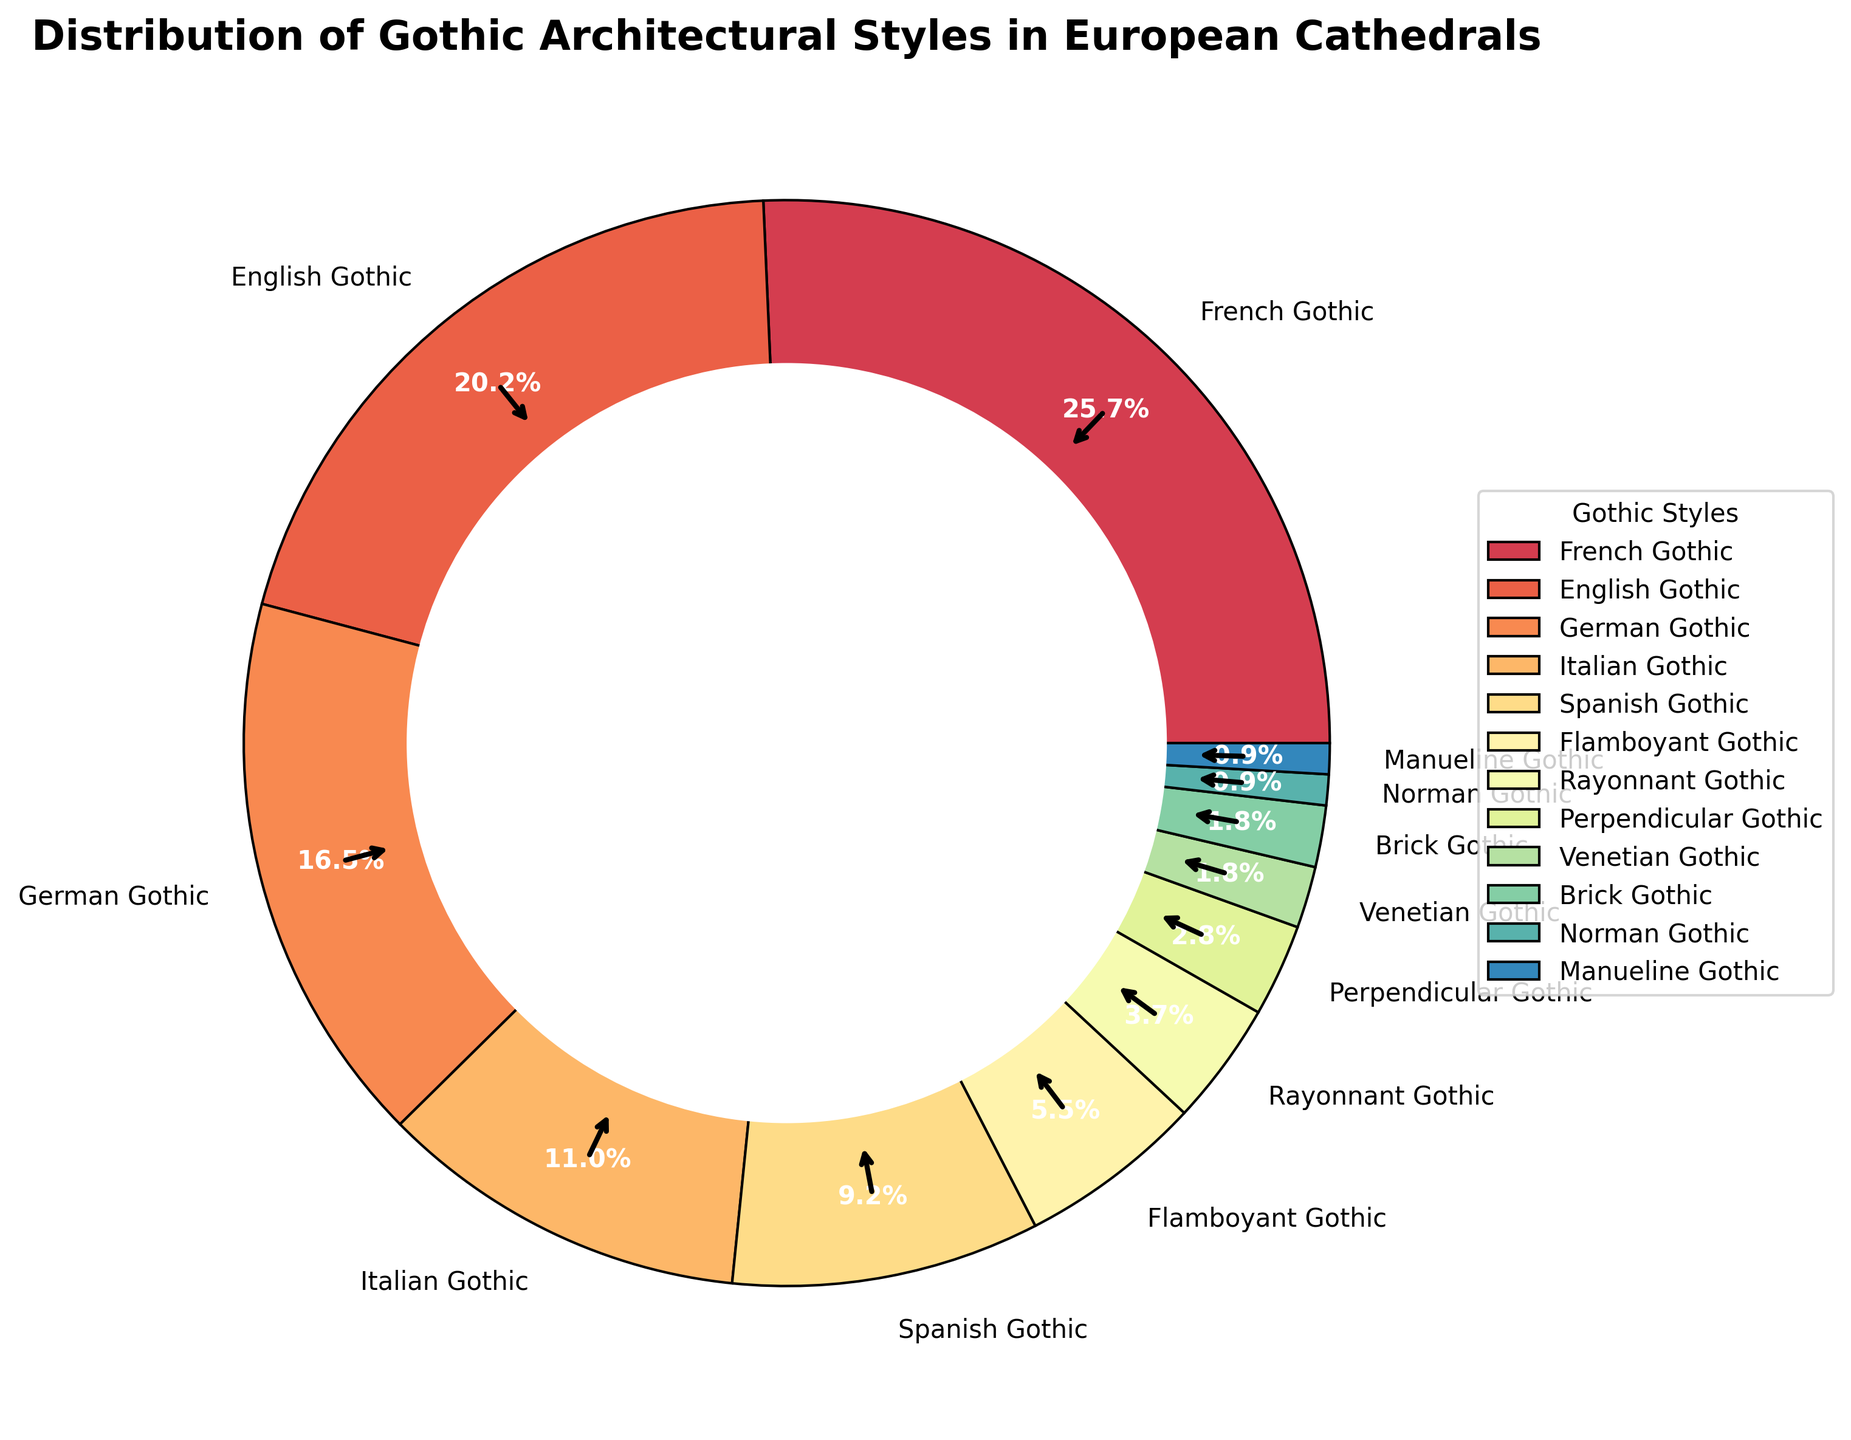What percentage of cathedrals exhibit French Gothic style? To find this information, look at the sector labeled "French Gothic" in the pie chart and note the percentage displayed on it.
Answer: 28% Of the main Gothic styles (French, English, German, Italian, and Spanish), which style has the smallest representation percentage? Among the prominent styles, look at the sectors labeled "French Gothic", "English Gothic", "German Gothic", "Italian Gothic", and "Spanish Gothic". Compare the percentages and identify the smallest.
Answer: Spanish Gothic How much larger is the percentage of French Gothic compared to Brick Gothic? Locate the percentages for "French Gothic" and "Brick Gothic", then subtract the Brick Gothic percentage from the French Gothic percentage. French Gothic is 28% and Brick Gothic is 2%, so the difference is 28% - 2%.
Answer: 26% Which two styles have the smallest segments in the pie chart? Find the smallest sectors in the pie chart and read their labels to identify the corresponding styles.
Answer: Norman Gothic and Manueline Gothic What is the combined percentage of Flamboyant Gothic, Rayonnant Gothic, and Perpendicular Gothic styles? Look for the percentages of "Flamboyant Gothic" (6%), "Rayonnant Gothic" (4%), and "Perpendicular Gothic" (3%), then add them together. 6% + 4% + 3% = 13%
Answer: 13% If a new style was discovered and it took away 5% from the French Gothic percentage, what would the new percentage of French Gothic be? Start with the current French Gothic percentage of 28%, then subtract 5% to find the new percentage. 28% - 5% = 23%
Answer: 23% Which Gothic style immediately follows English Gothic in terms of percentage size? Identify the sector for "English Gothic" (22%), then look for the next smaller sector in the sequence, which is "German Gothic" at 18%.
Answer: German Gothic By how much does the percentage of English Gothic exceed that of Italian Gothic? Locate the percentages for "English Gothic" (22%) and "Italian Gothic" (12%), then subtract the Italian Gothic percentage from the English Gothic percentage. 22% - 12%
Answer: 10% How many styles have a percentage less than 5%? Count the sectors in the pie chart labeled with percentages less than 5%. The sectors are Rayonnant Gothic (4%), Perpendicular Gothic (3%), Venetian Gothic (2%), Brick Gothic (2%), Norman Gothic (1%), and Manueline Gothic (1%). This provides a count of 6.
Answer: 6 